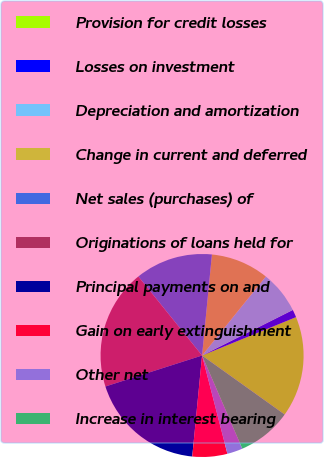Convert chart to OTSL. <chart><loc_0><loc_0><loc_500><loc_500><pie_chart><fcel>Provision for credit losses<fcel>Losses on investment<fcel>Depreciation and amortization<fcel>Change in current and deferred<fcel>Net sales (purchases) of<fcel>Originations of loans held for<fcel>Principal payments on and<fcel>Gain on early extinguishment<fcel>Other net<fcel>Increase in interest bearing<nl><fcel>16.05%<fcel>1.23%<fcel>6.79%<fcel>9.26%<fcel>12.35%<fcel>19.14%<fcel>18.52%<fcel>5.56%<fcel>2.47%<fcel>8.64%<nl></chart> 